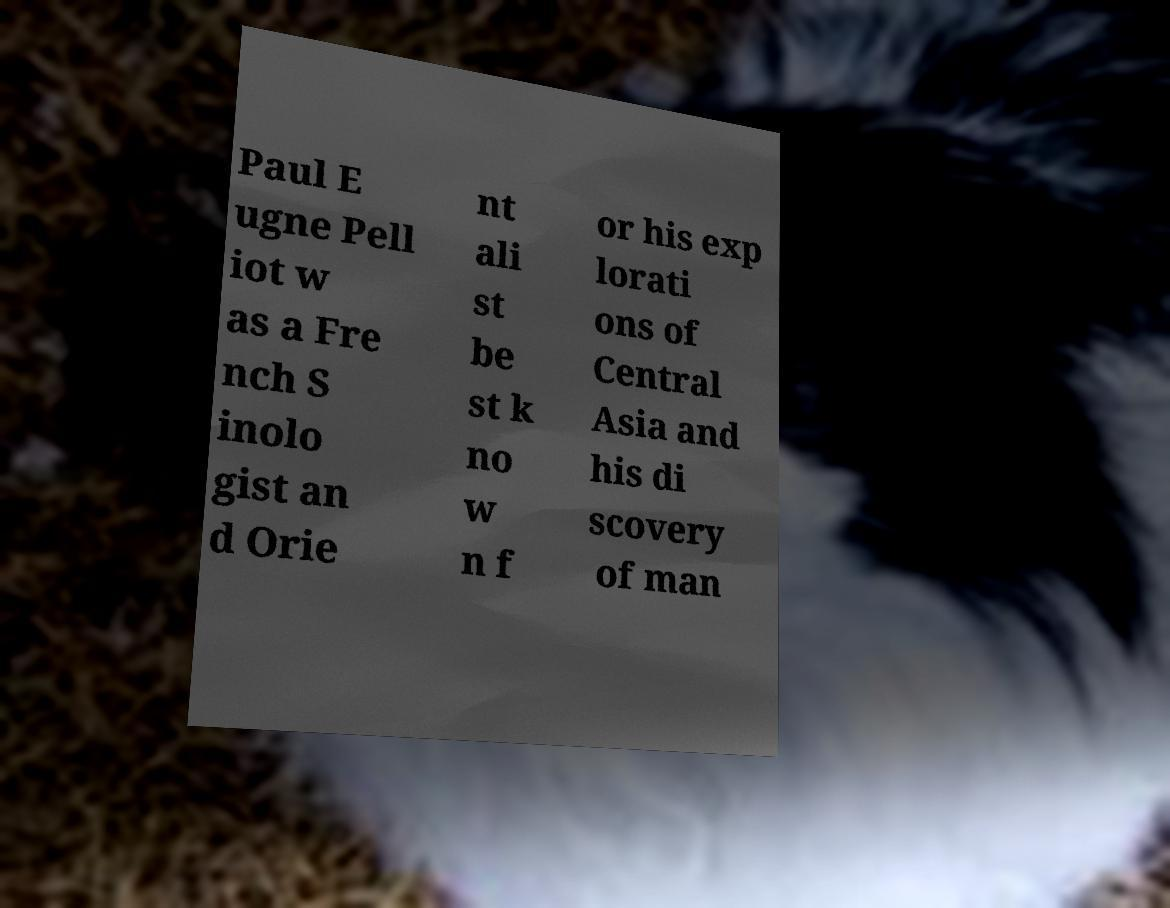Could you assist in decoding the text presented in this image and type it out clearly? Paul E ugne Pell iot w as a Fre nch S inolo gist an d Orie nt ali st be st k no w n f or his exp lorati ons of Central Asia and his di scovery of man 